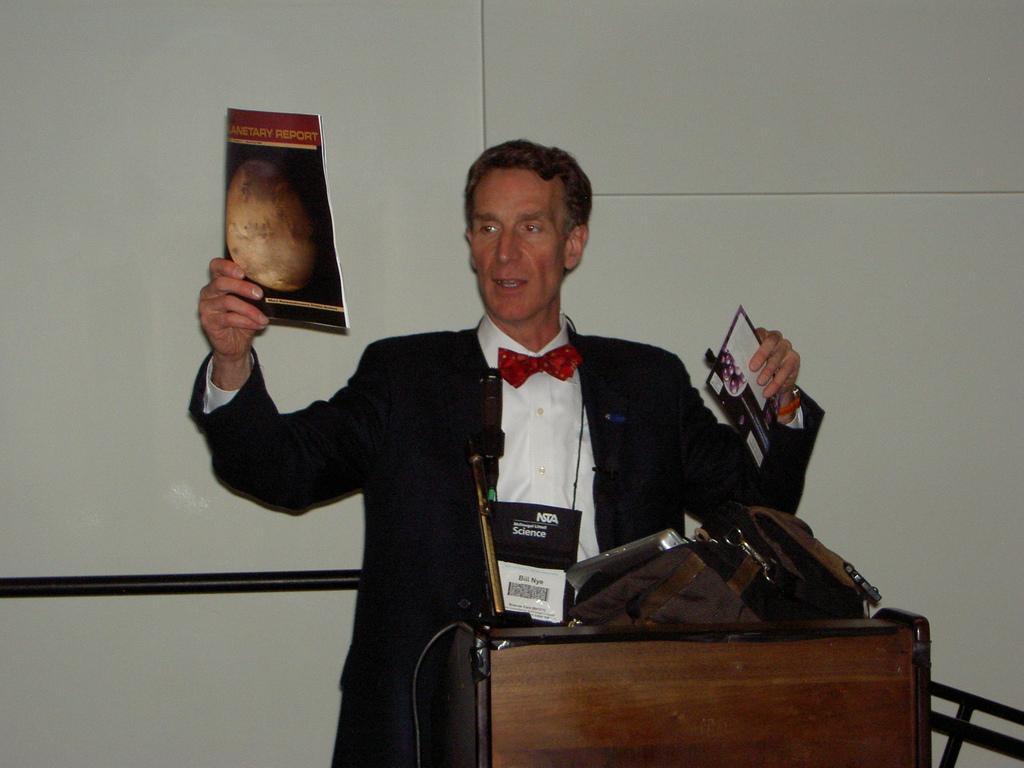Describe this image in one or two sentences. In this image we can see there is a person standing and holding papers. In front of the person there is a table, on the table there is a bag. At the back there is a rod and the wall. 